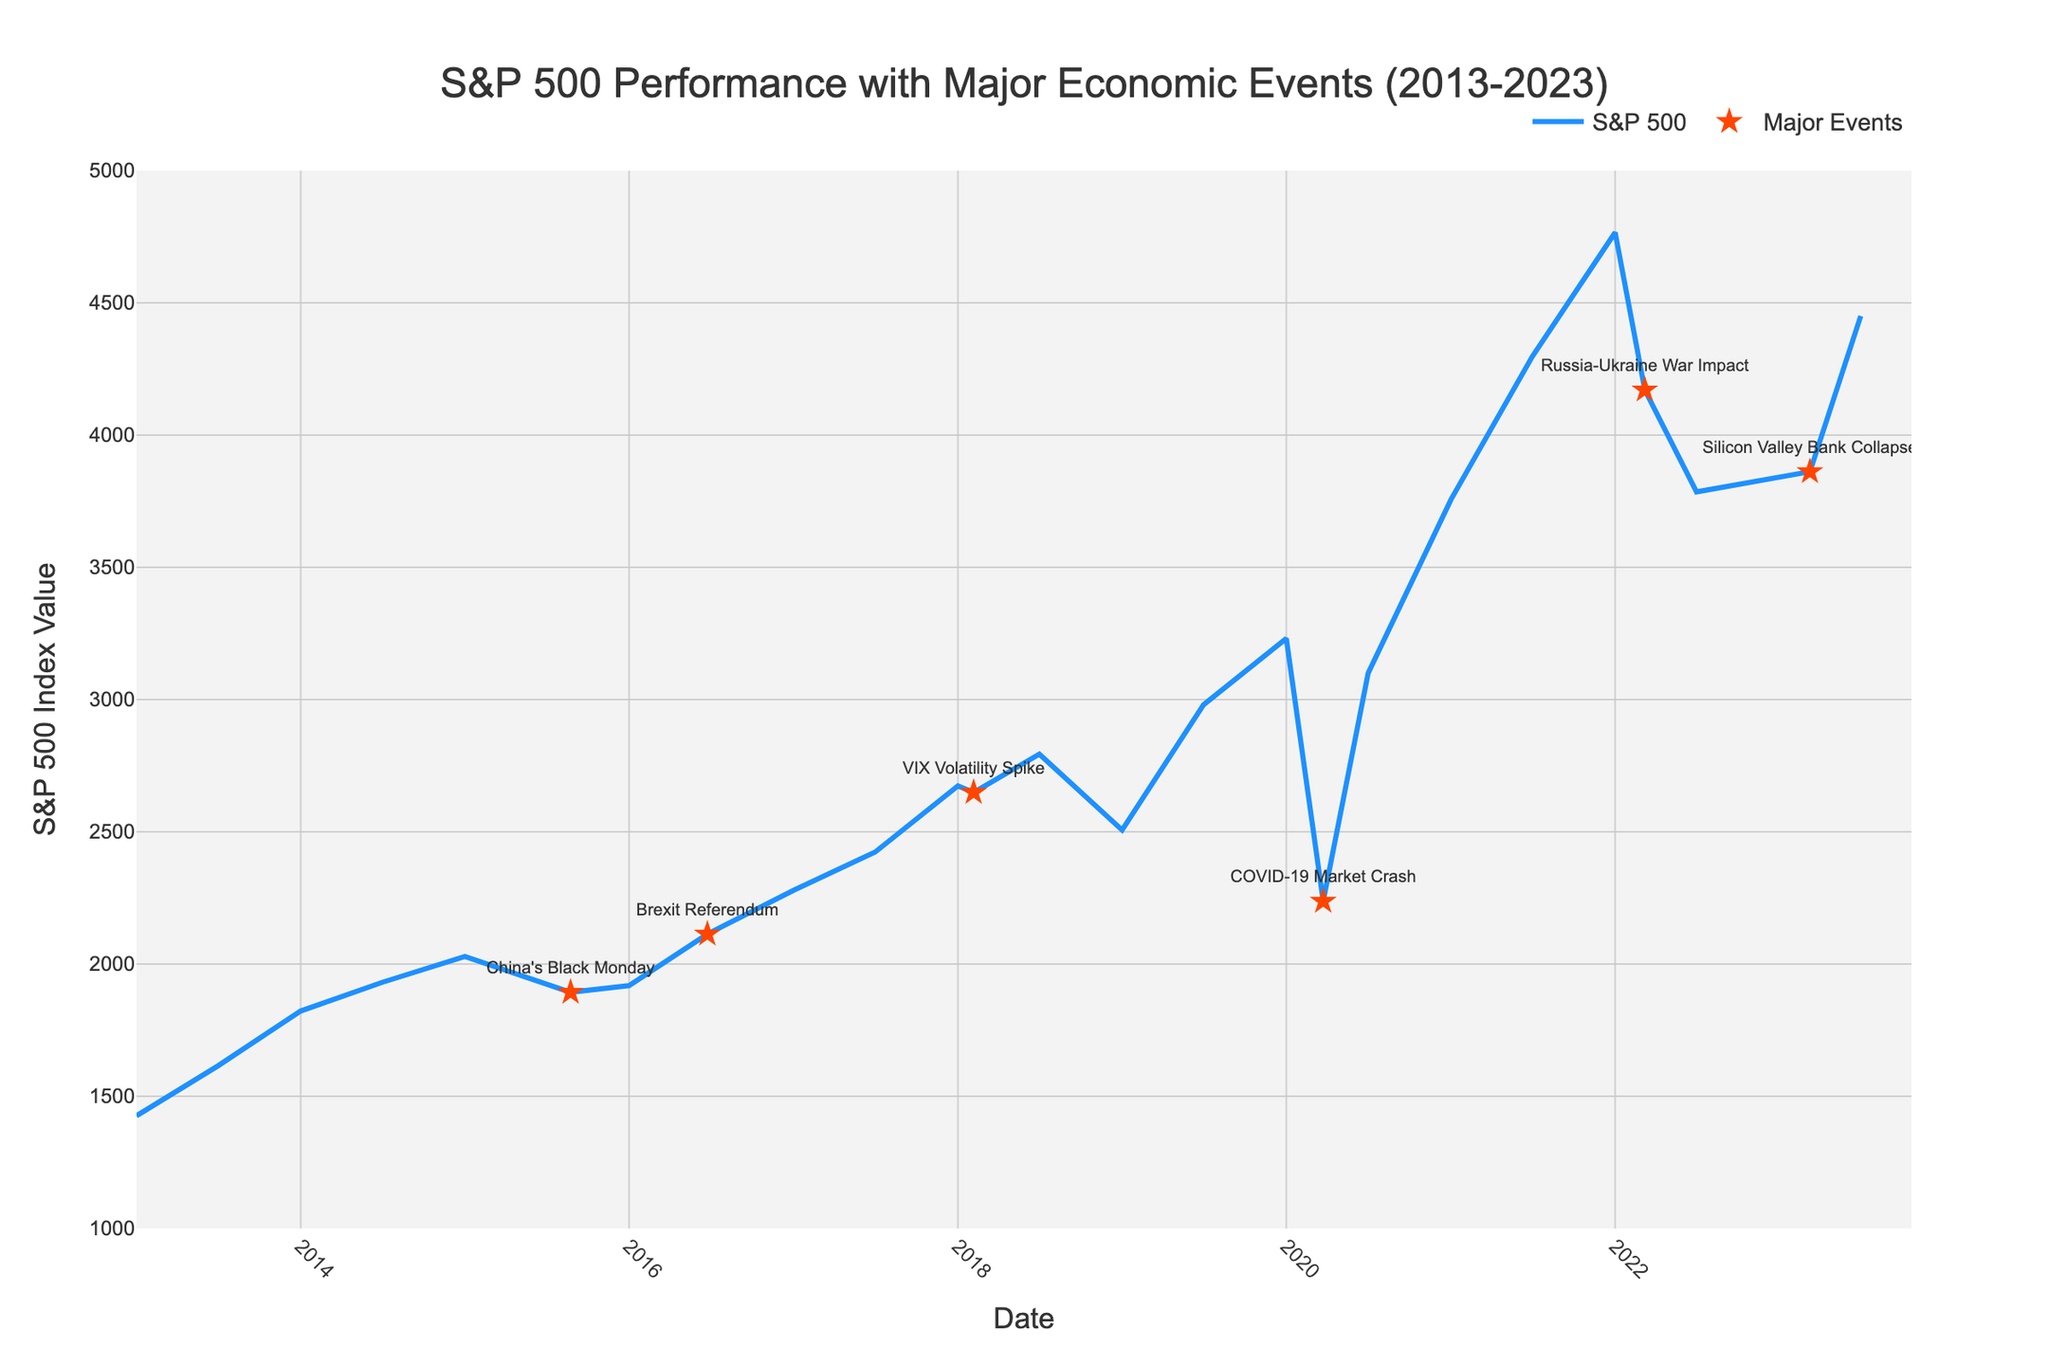What major event in the figure resulted in the sharpest drop in the S&P 500 index value within the span of a few months? The sharpest drop can be observed around March 2020, and it corresponds to the event labeled "COVID-19 Market Crash". The index value dropped from around 3,230.78 in January 2020 to approximately 2,237.40 by March 2020.
Answer: COVID-19 Market Crash How did the S&P 500 index value change from the Brexit Referendum to the start of 2017? On June 23, 2016 (Brexit Referendum), the S&P 500 value was at 2,113.32. By January 1, 2017, it had increased to 2,278.87. The change is calculated as 2,278.87 - 2,113.32 = 165.55.
Answer: Increased by 165.55 Which economic event led to the lowest index value in the plot? The lowest index value on the plot, 2,237.40, occurred on March 23, 2020, during the "COVID-19 Market Crash".
Answer: COVID-19 Market Crash What was the S&P 500 index value on the date closest to the Silicon Valley Bank Collapse? The index value on March 10, 2023 (Silicon Valley Bank Collapse) was 3,861.59.
Answer: 3,861.59 Between the Russia-Ukraine War Impact and July 2022, did the S&P 500 index value increase or decrease, and by how much? On March 8, 2022 (Russia-Ukraine War Impact), the index value was 4,170.70. By July 1, 2022, it had decreased to 3,785.38. The change is calculated as 4,170.70 - 3,785.38 = 385.32.
Answer: Decreased by 385.32 Compare the S&P 500 index value at the start of 2019 and 2020. Is there an increase or decrease, and what is the difference? At the start of 2019, the index value was 2,506.85. At the start of 2020, it was 3,230.78. The change is 3,230.78 - 2,506.85 = 723.93.
Answer: Increased by 723.93 What was the trend in the S&P 500 index value between the start of 2022 and July 2023? The index value decreased from 4,766.18 on January 1, 2022, to 3,839.50 on January 1, 2023, and then increased to 4,450.38 by July 1, 2023. This shows a drop followed by a recovery.
Answer: Drop followed by recovery Based on the visual attributes, which color and marker shape represent major economic events? Major economic events are represented by star-shaped red markers.
Answer: Red star-shaped markers 